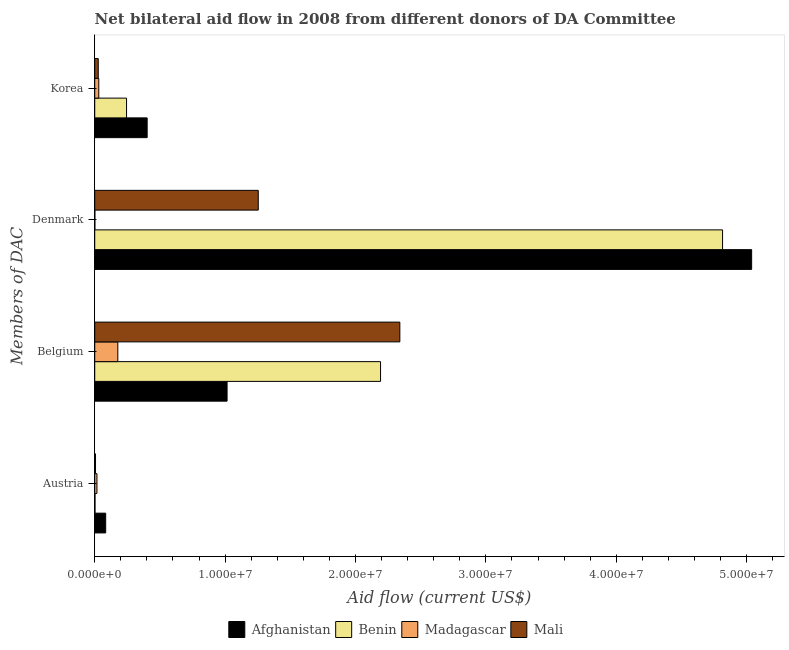How many bars are there on the 1st tick from the bottom?
Offer a terse response. 4. What is the label of the 1st group of bars from the top?
Keep it short and to the point. Korea. What is the amount of aid given by austria in Madagascar?
Your answer should be very brief. 1.70e+05. Across all countries, what is the maximum amount of aid given by austria?
Give a very brief answer. 8.40e+05. Across all countries, what is the minimum amount of aid given by korea?
Keep it short and to the point. 2.70e+05. In which country was the amount of aid given by korea maximum?
Offer a very short reply. Afghanistan. In which country was the amount of aid given by austria minimum?
Give a very brief answer. Benin. What is the total amount of aid given by denmark in the graph?
Offer a very short reply. 1.11e+08. What is the difference between the amount of aid given by belgium in Madagascar and that in Mali?
Provide a short and direct response. -2.16e+07. What is the difference between the amount of aid given by austria in Benin and the amount of aid given by denmark in Madagascar?
Give a very brief answer. 10000. What is the average amount of aid given by belgium per country?
Your answer should be very brief. 1.43e+07. What is the difference between the amount of aid given by belgium and amount of aid given by korea in Madagascar?
Your answer should be very brief. 1.46e+06. In how many countries, is the amount of aid given by belgium greater than 6000000 US$?
Your response must be concise. 3. What is the ratio of the amount of aid given by austria in Benin to that in Madagascar?
Your answer should be compact. 0.12. Is the amount of aid given by denmark in Mali less than that in Afghanistan?
Keep it short and to the point. Yes. Is the difference between the amount of aid given by korea in Mali and Madagascar greater than the difference between the amount of aid given by belgium in Mali and Madagascar?
Provide a short and direct response. No. What is the difference between the highest and the second highest amount of aid given by belgium?
Your answer should be compact. 1.48e+06. What is the difference between the highest and the lowest amount of aid given by korea?
Ensure brevity in your answer.  3.75e+06. Is the sum of the amount of aid given by denmark in Madagascar and Afghanistan greater than the maximum amount of aid given by korea across all countries?
Your answer should be compact. Yes. Is it the case that in every country, the sum of the amount of aid given by austria and amount of aid given by belgium is greater than the sum of amount of aid given by denmark and amount of aid given by korea?
Make the answer very short. No. What does the 3rd bar from the top in Denmark represents?
Offer a very short reply. Benin. What does the 2nd bar from the bottom in Denmark represents?
Your answer should be compact. Benin. How many bars are there?
Keep it short and to the point. 16. Are all the bars in the graph horizontal?
Provide a succinct answer. Yes. What is the difference between two consecutive major ticks on the X-axis?
Offer a terse response. 1.00e+07. Where does the legend appear in the graph?
Keep it short and to the point. Bottom center. How are the legend labels stacked?
Your answer should be compact. Horizontal. What is the title of the graph?
Ensure brevity in your answer.  Net bilateral aid flow in 2008 from different donors of DA Committee. What is the label or title of the Y-axis?
Keep it short and to the point. Members of DAC. What is the Aid flow (current US$) in Afghanistan in Austria?
Make the answer very short. 8.40e+05. What is the Aid flow (current US$) of Afghanistan in Belgium?
Give a very brief answer. 1.02e+07. What is the Aid flow (current US$) in Benin in Belgium?
Your answer should be very brief. 2.19e+07. What is the Aid flow (current US$) of Madagascar in Belgium?
Your answer should be compact. 1.77e+06. What is the Aid flow (current US$) of Mali in Belgium?
Your response must be concise. 2.34e+07. What is the Aid flow (current US$) in Afghanistan in Denmark?
Your answer should be very brief. 5.04e+07. What is the Aid flow (current US$) in Benin in Denmark?
Make the answer very short. 4.82e+07. What is the Aid flow (current US$) in Mali in Denmark?
Make the answer very short. 1.25e+07. What is the Aid flow (current US$) in Afghanistan in Korea?
Give a very brief answer. 4.02e+06. What is the Aid flow (current US$) of Benin in Korea?
Your answer should be compact. 2.44e+06. What is the Aid flow (current US$) of Mali in Korea?
Keep it short and to the point. 2.70e+05. Across all Members of DAC, what is the maximum Aid flow (current US$) in Afghanistan?
Keep it short and to the point. 5.04e+07. Across all Members of DAC, what is the maximum Aid flow (current US$) in Benin?
Make the answer very short. 4.82e+07. Across all Members of DAC, what is the maximum Aid flow (current US$) in Madagascar?
Offer a very short reply. 1.77e+06. Across all Members of DAC, what is the maximum Aid flow (current US$) in Mali?
Offer a terse response. 2.34e+07. Across all Members of DAC, what is the minimum Aid flow (current US$) of Afghanistan?
Make the answer very short. 8.40e+05. Across all Members of DAC, what is the minimum Aid flow (current US$) of Benin?
Keep it short and to the point. 2.00e+04. Across all Members of DAC, what is the minimum Aid flow (current US$) in Madagascar?
Your answer should be very brief. 10000. What is the total Aid flow (current US$) of Afghanistan in the graph?
Make the answer very short. 6.54e+07. What is the total Aid flow (current US$) in Benin in the graph?
Your response must be concise. 7.25e+07. What is the total Aid flow (current US$) in Madagascar in the graph?
Provide a short and direct response. 2.26e+06. What is the total Aid flow (current US$) in Mali in the graph?
Offer a very short reply. 3.63e+07. What is the difference between the Aid flow (current US$) in Afghanistan in Austria and that in Belgium?
Ensure brevity in your answer.  -9.31e+06. What is the difference between the Aid flow (current US$) in Benin in Austria and that in Belgium?
Give a very brief answer. -2.19e+07. What is the difference between the Aid flow (current US$) in Madagascar in Austria and that in Belgium?
Offer a terse response. -1.60e+06. What is the difference between the Aid flow (current US$) of Mali in Austria and that in Belgium?
Your answer should be compact. -2.33e+07. What is the difference between the Aid flow (current US$) of Afghanistan in Austria and that in Denmark?
Offer a terse response. -4.95e+07. What is the difference between the Aid flow (current US$) in Benin in Austria and that in Denmark?
Make the answer very short. -4.81e+07. What is the difference between the Aid flow (current US$) in Madagascar in Austria and that in Denmark?
Offer a very short reply. 1.60e+05. What is the difference between the Aid flow (current US$) of Mali in Austria and that in Denmark?
Provide a short and direct response. -1.25e+07. What is the difference between the Aid flow (current US$) of Afghanistan in Austria and that in Korea?
Offer a very short reply. -3.18e+06. What is the difference between the Aid flow (current US$) in Benin in Austria and that in Korea?
Make the answer very short. -2.42e+06. What is the difference between the Aid flow (current US$) of Afghanistan in Belgium and that in Denmark?
Your response must be concise. -4.02e+07. What is the difference between the Aid flow (current US$) in Benin in Belgium and that in Denmark?
Make the answer very short. -2.62e+07. What is the difference between the Aid flow (current US$) in Madagascar in Belgium and that in Denmark?
Provide a succinct answer. 1.76e+06. What is the difference between the Aid flow (current US$) of Mali in Belgium and that in Denmark?
Provide a succinct answer. 1.09e+07. What is the difference between the Aid flow (current US$) in Afghanistan in Belgium and that in Korea?
Your answer should be very brief. 6.13e+06. What is the difference between the Aid flow (current US$) of Benin in Belgium and that in Korea?
Ensure brevity in your answer.  1.95e+07. What is the difference between the Aid flow (current US$) of Madagascar in Belgium and that in Korea?
Offer a very short reply. 1.46e+06. What is the difference between the Aid flow (current US$) in Mali in Belgium and that in Korea?
Your answer should be compact. 2.31e+07. What is the difference between the Aid flow (current US$) of Afghanistan in Denmark and that in Korea?
Provide a succinct answer. 4.64e+07. What is the difference between the Aid flow (current US$) in Benin in Denmark and that in Korea?
Provide a succinct answer. 4.57e+07. What is the difference between the Aid flow (current US$) in Madagascar in Denmark and that in Korea?
Provide a succinct answer. -3.00e+05. What is the difference between the Aid flow (current US$) in Mali in Denmark and that in Korea?
Offer a very short reply. 1.23e+07. What is the difference between the Aid flow (current US$) of Afghanistan in Austria and the Aid flow (current US$) of Benin in Belgium?
Ensure brevity in your answer.  -2.11e+07. What is the difference between the Aid flow (current US$) of Afghanistan in Austria and the Aid flow (current US$) of Madagascar in Belgium?
Provide a short and direct response. -9.30e+05. What is the difference between the Aid flow (current US$) of Afghanistan in Austria and the Aid flow (current US$) of Mali in Belgium?
Keep it short and to the point. -2.26e+07. What is the difference between the Aid flow (current US$) in Benin in Austria and the Aid flow (current US$) in Madagascar in Belgium?
Give a very brief answer. -1.75e+06. What is the difference between the Aid flow (current US$) in Benin in Austria and the Aid flow (current US$) in Mali in Belgium?
Ensure brevity in your answer.  -2.34e+07. What is the difference between the Aid flow (current US$) of Madagascar in Austria and the Aid flow (current US$) of Mali in Belgium?
Keep it short and to the point. -2.32e+07. What is the difference between the Aid flow (current US$) of Afghanistan in Austria and the Aid flow (current US$) of Benin in Denmark?
Ensure brevity in your answer.  -4.73e+07. What is the difference between the Aid flow (current US$) in Afghanistan in Austria and the Aid flow (current US$) in Madagascar in Denmark?
Your answer should be very brief. 8.30e+05. What is the difference between the Aid flow (current US$) in Afghanistan in Austria and the Aid flow (current US$) in Mali in Denmark?
Offer a very short reply. -1.17e+07. What is the difference between the Aid flow (current US$) of Benin in Austria and the Aid flow (current US$) of Mali in Denmark?
Your response must be concise. -1.25e+07. What is the difference between the Aid flow (current US$) in Madagascar in Austria and the Aid flow (current US$) in Mali in Denmark?
Ensure brevity in your answer.  -1.24e+07. What is the difference between the Aid flow (current US$) in Afghanistan in Austria and the Aid flow (current US$) in Benin in Korea?
Ensure brevity in your answer.  -1.60e+06. What is the difference between the Aid flow (current US$) of Afghanistan in Austria and the Aid flow (current US$) of Madagascar in Korea?
Your answer should be compact. 5.30e+05. What is the difference between the Aid flow (current US$) in Afghanistan in Austria and the Aid flow (current US$) in Mali in Korea?
Provide a short and direct response. 5.70e+05. What is the difference between the Aid flow (current US$) of Madagascar in Austria and the Aid flow (current US$) of Mali in Korea?
Keep it short and to the point. -1.00e+05. What is the difference between the Aid flow (current US$) in Afghanistan in Belgium and the Aid flow (current US$) in Benin in Denmark?
Make the answer very short. -3.80e+07. What is the difference between the Aid flow (current US$) in Afghanistan in Belgium and the Aid flow (current US$) in Madagascar in Denmark?
Keep it short and to the point. 1.01e+07. What is the difference between the Aid flow (current US$) of Afghanistan in Belgium and the Aid flow (current US$) of Mali in Denmark?
Offer a very short reply. -2.39e+06. What is the difference between the Aid flow (current US$) in Benin in Belgium and the Aid flow (current US$) in Madagascar in Denmark?
Give a very brief answer. 2.19e+07. What is the difference between the Aid flow (current US$) in Benin in Belgium and the Aid flow (current US$) in Mali in Denmark?
Give a very brief answer. 9.38e+06. What is the difference between the Aid flow (current US$) of Madagascar in Belgium and the Aid flow (current US$) of Mali in Denmark?
Keep it short and to the point. -1.08e+07. What is the difference between the Aid flow (current US$) in Afghanistan in Belgium and the Aid flow (current US$) in Benin in Korea?
Your answer should be very brief. 7.71e+06. What is the difference between the Aid flow (current US$) of Afghanistan in Belgium and the Aid flow (current US$) of Madagascar in Korea?
Make the answer very short. 9.84e+06. What is the difference between the Aid flow (current US$) of Afghanistan in Belgium and the Aid flow (current US$) of Mali in Korea?
Keep it short and to the point. 9.88e+06. What is the difference between the Aid flow (current US$) of Benin in Belgium and the Aid flow (current US$) of Madagascar in Korea?
Your answer should be compact. 2.16e+07. What is the difference between the Aid flow (current US$) of Benin in Belgium and the Aid flow (current US$) of Mali in Korea?
Offer a very short reply. 2.16e+07. What is the difference between the Aid flow (current US$) in Madagascar in Belgium and the Aid flow (current US$) in Mali in Korea?
Provide a short and direct response. 1.50e+06. What is the difference between the Aid flow (current US$) of Afghanistan in Denmark and the Aid flow (current US$) of Benin in Korea?
Your response must be concise. 4.79e+07. What is the difference between the Aid flow (current US$) in Afghanistan in Denmark and the Aid flow (current US$) in Madagascar in Korea?
Your answer should be compact. 5.01e+07. What is the difference between the Aid flow (current US$) in Afghanistan in Denmark and the Aid flow (current US$) in Mali in Korea?
Ensure brevity in your answer.  5.01e+07. What is the difference between the Aid flow (current US$) of Benin in Denmark and the Aid flow (current US$) of Madagascar in Korea?
Your response must be concise. 4.78e+07. What is the difference between the Aid flow (current US$) of Benin in Denmark and the Aid flow (current US$) of Mali in Korea?
Give a very brief answer. 4.79e+07. What is the difference between the Aid flow (current US$) of Madagascar in Denmark and the Aid flow (current US$) of Mali in Korea?
Ensure brevity in your answer.  -2.60e+05. What is the average Aid flow (current US$) in Afghanistan per Members of DAC?
Your response must be concise. 1.63e+07. What is the average Aid flow (current US$) in Benin per Members of DAC?
Give a very brief answer. 1.81e+07. What is the average Aid flow (current US$) of Madagascar per Members of DAC?
Ensure brevity in your answer.  5.65e+05. What is the average Aid flow (current US$) of Mali per Members of DAC?
Provide a short and direct response. 9.07e+06. What is the difference between the Aid flow (current US$) in Afghanistan and Aid flow (current US$) in Benin in Austria?
Keep it short and to the point. 8.20e+05. What is the difference between the Aid flow (current US$) of Afghanistan and Aid flow (current US$) of Madagascar in Austria?
Keep it short and to the point. 6.70e+05. What is the difference between the Aid flow (current US$) in Afghanistan and Aid flow (current US$) in Mali in Austria?
Offer a very short reply. 7.80e+05. What is the difference between the Aid flow (current US$) in Benin and Aid flow (current US$) in Madagascar in Austria?
Give a very brief answer. -1.50e+05. What is the difference between the Aid flow (current US$) of Benin and Aid flow (current US$) of Mali in Austria?
Provide a short and direct response. -4.00e+04. What is the difference between the Aid flow (current US$) in Madagascar and Aid flow (current US$) in Mali in Austria?
Give a very brief answer. 1.10e+05. What is the difference between the Aid flow (current US$) in Afghanistan and Aid flow (current US$) in Benin in Belgium?
Your response must be concise. -1.18e+07. What is the difference between the Aid flow (current US$) of Afghanistan and Aid flow (current US$) of Madagascar in Belgium?
Ensure brevity in your answer.  8.38e+06. What is the difference between the Aid flow (current US$) in Afghanistan and Aid flow (current US$) in Mali in Belgium?
Keep it short and to the point. -1.32e+07. What is the difference between the Aid flow (current US$) in Benin and Aid flow (current US$) in Madagascar in Belgium?
Offer a very short reply. 2.02e+07. What is the difference between the Aid flow (current US$) in Benin and Aid flow (current US$) in Mali in Belgium?
Your response must be concise. -1.48e+06. What is the difference between the Aid flow (current US$) of Madagascar and Aid flow (current US$) of Mali in Belgium?
Make the answer very short. -2.16e+07. What is the difference between the Aid flow (current US$) in Afghanistan and Aid flow (current US$) in Benin in Denmark?
Offer a very short reply. 2.23e+06. What is the difference between the Aid flow (current US$) in Afghanistan and Aid flow (current US$) in Madagascar in Denmark?
Offer a terse response. 5.04e+07. What is the difference between the Aid flow (current US$) in Afghanistan and Aid flow (current US$) in Mali in Denmark?
Provide a succinct answer. 3.78e+07. What is the difference between the Aid flow (current US$) in Benin and Aid flow (current US$) in Madagascar in Denmark?
Offer a very short reply. 4.81e+07. What is the difference between the Aid flow (current US$) of Benin and Aid flow (current US$) of Mali in Denmark?
Give a very brief answer. 3.56e+07. What is the difference between the Aid flow (current US$) of Madagascar and Aid flow (current US$) of Mali in Denmark?
Offer a terse response. -1.25e+07. What is the difference between the Aid flow (current US$) of Afghanistan and Aid flow (current US$) of Benin in Korea?
Ensure brevity in your answer.  1.58e+06. What is the difference between the Aid flow (current US$) in Afghanistan and Aid flow (current US$) in Madagascar in Korea?
Ensure brevity in your answer.  3.71e+06. What is the difference between the Aid flow (current US$) in Afghanistan and Aid flow (current US$) in Mali in Korea?
Your answer should be very brief. 3.75e+06. What is the difference between the Aid flow (current US$) in Benin and Aid flow (current US$) in Madagascar in Korea?
Offer a very short reply. 2.13e+06. What is the difference between the Aid flow (current US$) in Benin and Aid flow (current US$) in Mali in Korea?
Your response must be concise. 2.17e+06. What is the ratio of the Aid flow (current US$) in Afghanistan in Austria to that in Belgium?
Provide a succinct answer. 0.08. What is the ratio of the Aid flow (current US$) of Benin in Austria to that in Belgium?
Your response must be concise. 0. What is the ratio of the Aid flow (current US$) of Madagascar in Austria to that in Belgium?
Provide a succinct answer. 0.1. What is the ratio of the Aid flow (current US$) in Mali in Austria to that in Belgium?
Your answer should be very brief. 0. What is the ratio of the Aid flow (current US$) in Afghanistan in Austria to that in Denmark?
Ensure brevity in your answer.  0.02. What is the ratio of the Aid flow (current US$) of Benin in Austria to that in Denmark?
Provide a short and direct response. 0. What is the ratio of the Aid flow (current US$) of Madagascar in Austria to that in Denmark?
Provide a succinct answer. 17. What is the ratio of the Aid flow (current US$) in Mali in Austria to that in Denmark?
Keep it short and to the point. 0. What is the ratio of the Aid flow (current US$) in Afghanistan in Austria to that in Korea?
Offer a terse response. 0.21. What is the ratio of the Aid flow (current US$) of Benin in Austria to that in Korea?
Your answer should be very brief. 0.01. What is the ratio of the Aid flow (current US$) in Madagascar in Austria to that in Korea?
Your answer should be compact. 0.55. What is the ratio of the Aid flow (current US$) of Mali in Austria to that in Korea?
Ensure brevity in your answer.  0.22. What is the ratio of the Aid flow (current US$) of Afghanistan in Belgium to that in Denmark?
Offer a very short reply. 0.2. What is the ratio of the Aid flow (current US$) in Benin in Belgium to that in Denmark?
Provide a short and direct response. 0.46. What is the ratio of the Aid flow (current US$) of Madagascar in Belgium to that in Denmark?
Ensure brevity in your answer.  177. What is the ratio of the Aid flow (current US$) of Mali in Belgium to that in Denmark?
Offer a very short reply. 1.87. What is the ratio of the Aid flow (current US$) in Afghanistan in Belgium to that in Korea?
Make the answer very short. 2.52. What is the ratio of the Aid flow (current US$) in Benin in Belgium to that in Korea?
Your answer should be compact. 8.98. What is the ratio of the Aid flow (current US$) in Madagascar in Belgium to that in Korea?
Ensure brevity in your answer.  5.71. What is the ratio of the Aid flow (current US$) in Mali in Belgium to that in Korea?
Your answer should be compact. 86.67. What is the ratio of the Aid flow (current US$) in Afghanistan in Denmark to that in Korea?
Ensure brevity in your answer.  12.53. What is the ratio of the Aid flow (current US$) in Benin in Denmark to that in Korea?
Your answer should be very brief. 19.73. What is the ratio of the Aid flow (current US$) of Madagascar in Denmark to that in Korea?
Give a very brief answer. 0.03. What is the ratio of the Aid flow (current US$) of Mali in Denmark to that in Korea?
Make the answer very short. 46.44. What is the difference between the highest and the second highest Aid flow (current US$) of Afghanistan?
Offer a very short reply. 4.02e+07. What is the difference between the highest and the second highest Aid flow (current US$) of Benin?
Provide a succinct answer. 2.62e+07. What is the difference between the highest and the second highest Aid flow (current US$) in Madagascar?
Provide a short and direct response. 1.46e+06. What is the difference between the highest and the second highest Aid flow (current US$) of Mali?
Provide a succinct answer. 1.09e+07. What is the difference between the highest and the lowest Aid flow (current US$) in Afghanistan?
Give a very brief answer. 4.95e+07. What is the difference between the highest and the lowest Aid flow (current US$) of Benin?
Provide a short and direct response. 4.81e+07. What is the difference between the highest and the lowest Aid flow (current US$) in Madagascar?
Your answer should be compact. 1.76e+06. What is the difference between the highest and the lowest Aid flow (current US$) of Mali?
Keep it short and to the point. 2.33e+07. 